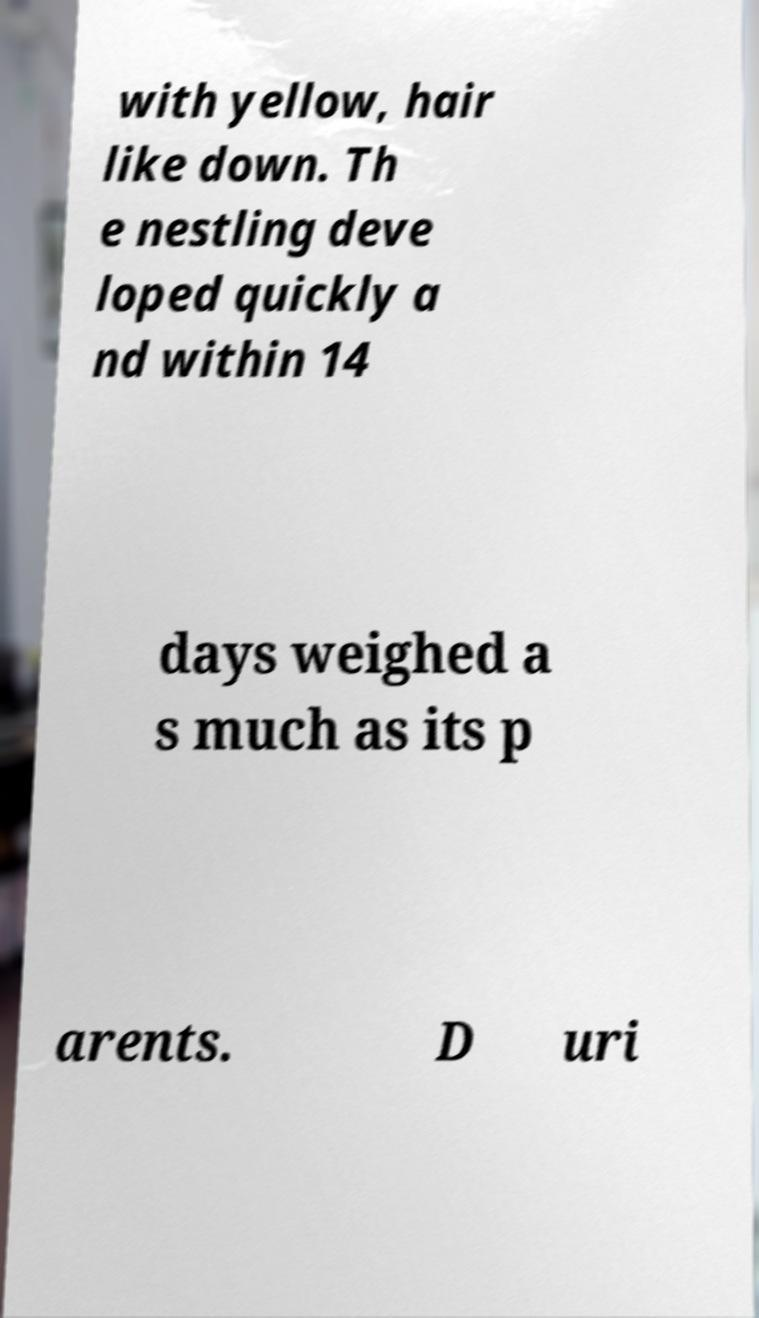Could you assist in decoding the text presented in this image and type it out clearly? with yellow, hair like down. Th e nestling deve loped quickly a nd within 14 days weighed a s much as its p arents. D uri 